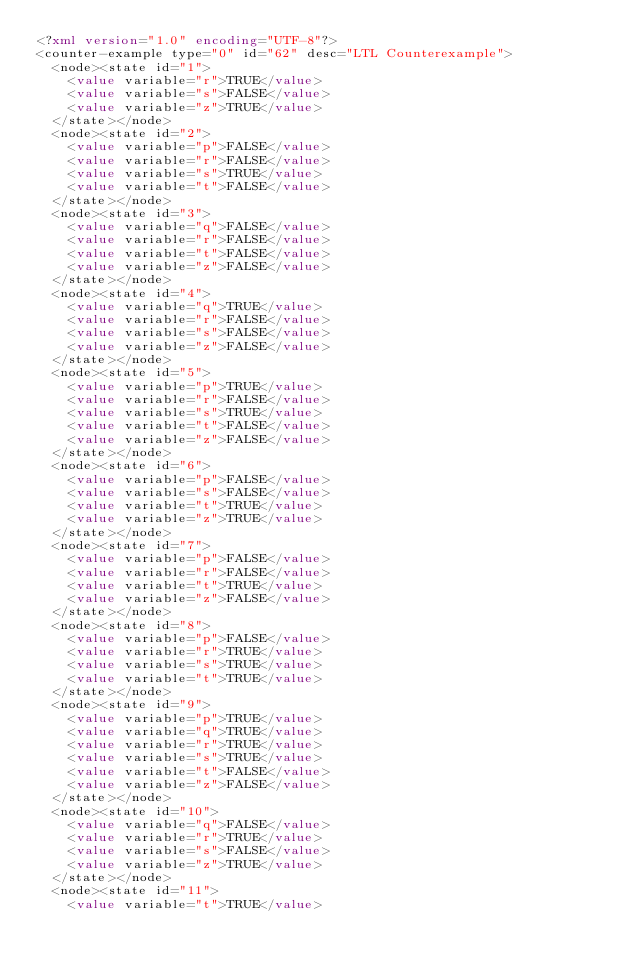<code> <loc_0><loc_0><loc_500><loc_500><_XML_><?xml version="1.0" encoding="UTF-8"?>
<counter-example type="0" id="62" desc="LTL Counterexample">
  <node><state id="1">
    <value variable="r">TRUE</value>
    <value variable="s">FALSE</value>
    <value variable="z">TRUE</value>
  </state></node>
  <node><state id="2">
    <value variable="p">FALSE</value>
    <value variable="r">FALSE</value>
    <value variable="s">TRUE</value>
    <value variable="t">FALSE</value>
  </state></node>
  <node><state id="3">
    <value variable="q">FALSE</value>
    <value variable="r">FALSE</value>
    <value variable="t">FALSE</value>
    <value variable="z">FALSE</value>
  </state></node>
  <node><state id="4">
    <value variable="q">TRUE</value>
    <value variable="r">FALSE</value>
    <value variable="s">FALSE</value>
    <value variable="z">FALSE</value>
  </state></node>
  <node><state id="5">
    <value variable="p">TRUE</value>
    <value variable="r">FALSE</value>
    <value variable="s">TRUE</value>
    <value variable="t">FALSE</value>
    <value variable="z">FALSE</value>
  </state></node>
  <node><state id="6">
    <value variable="p">FALSE</value>
    <value variable="s">FALSE</value>
    <value variable="t">TRUE</value>
    <value variable="z">TRUE</value>
  </state></node>
  <node><state id="7">
    <value variable="p">FALSE</value>
    <value variable="r">FALSE</value>
    <value variable="t">TRUE</value>
    <value variable="z">FALSE</value>
  </state></node>
  <node><state id="8">
    <value variable="p">FALSE</value>
    <value variable="r">TRUE</value>
    <value variable="s">TRUE</value>
    <value variable="t">TRUE</value>
  </state></node>
  <node><state id="9">
    <value variable="p">TRUE</value>
    <value variable="q">TRUE</value>
    <value variable="r">TRUE</value>
    <value variable="s">TRUE</value>
    <value variable="t">FALSE</value>
    <value variable="z">FALSE</value>
  </state></node>
  <node><state id="10">
    <value variable="q">FALSE</value>
    <value variable="r">TRUE</value>
    <value variable="s">FALSE</value>
    <value variable="z">TRUE</value>
  </state></node>
  <node><state id="11">
    <value variable="t">TRUE</value></code> 